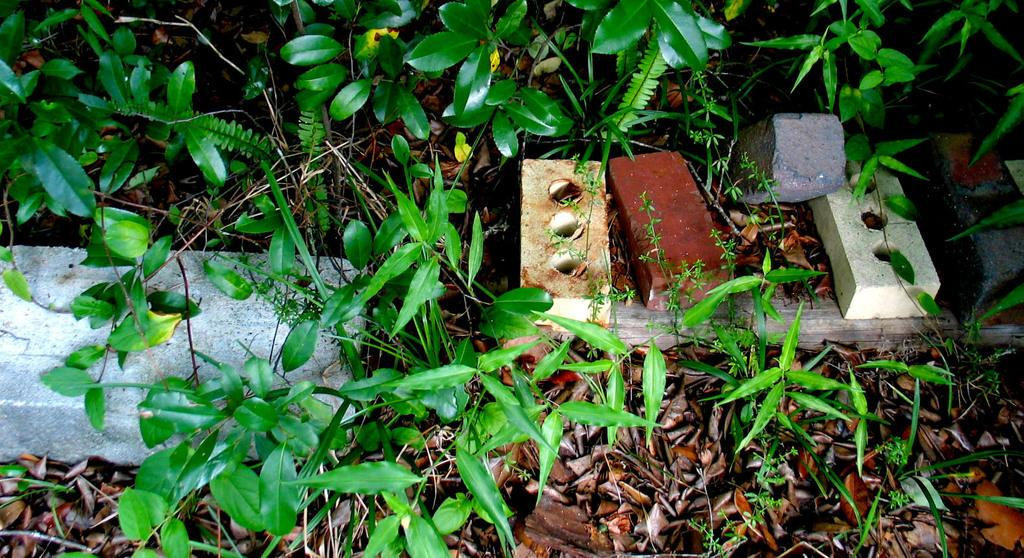What type of material can be seen on the land in the image? There are bricks on the land in the image. What else can be found on the ground in the image? There are dried leaves on the ground in the image. What type of vegetation is present in the image? There are plants in the image. What is the color of the plants in the image? The plants are green in color. Can you see any honey dripping from the plants in the image? There is no honey present in the image; it features plants and dried leaves on the ground. What type of creature can be seen interacting with the plants in the image? There is no creature shown interacting with the plants in the image; only the plants, bricks, and dried leaves are present. 